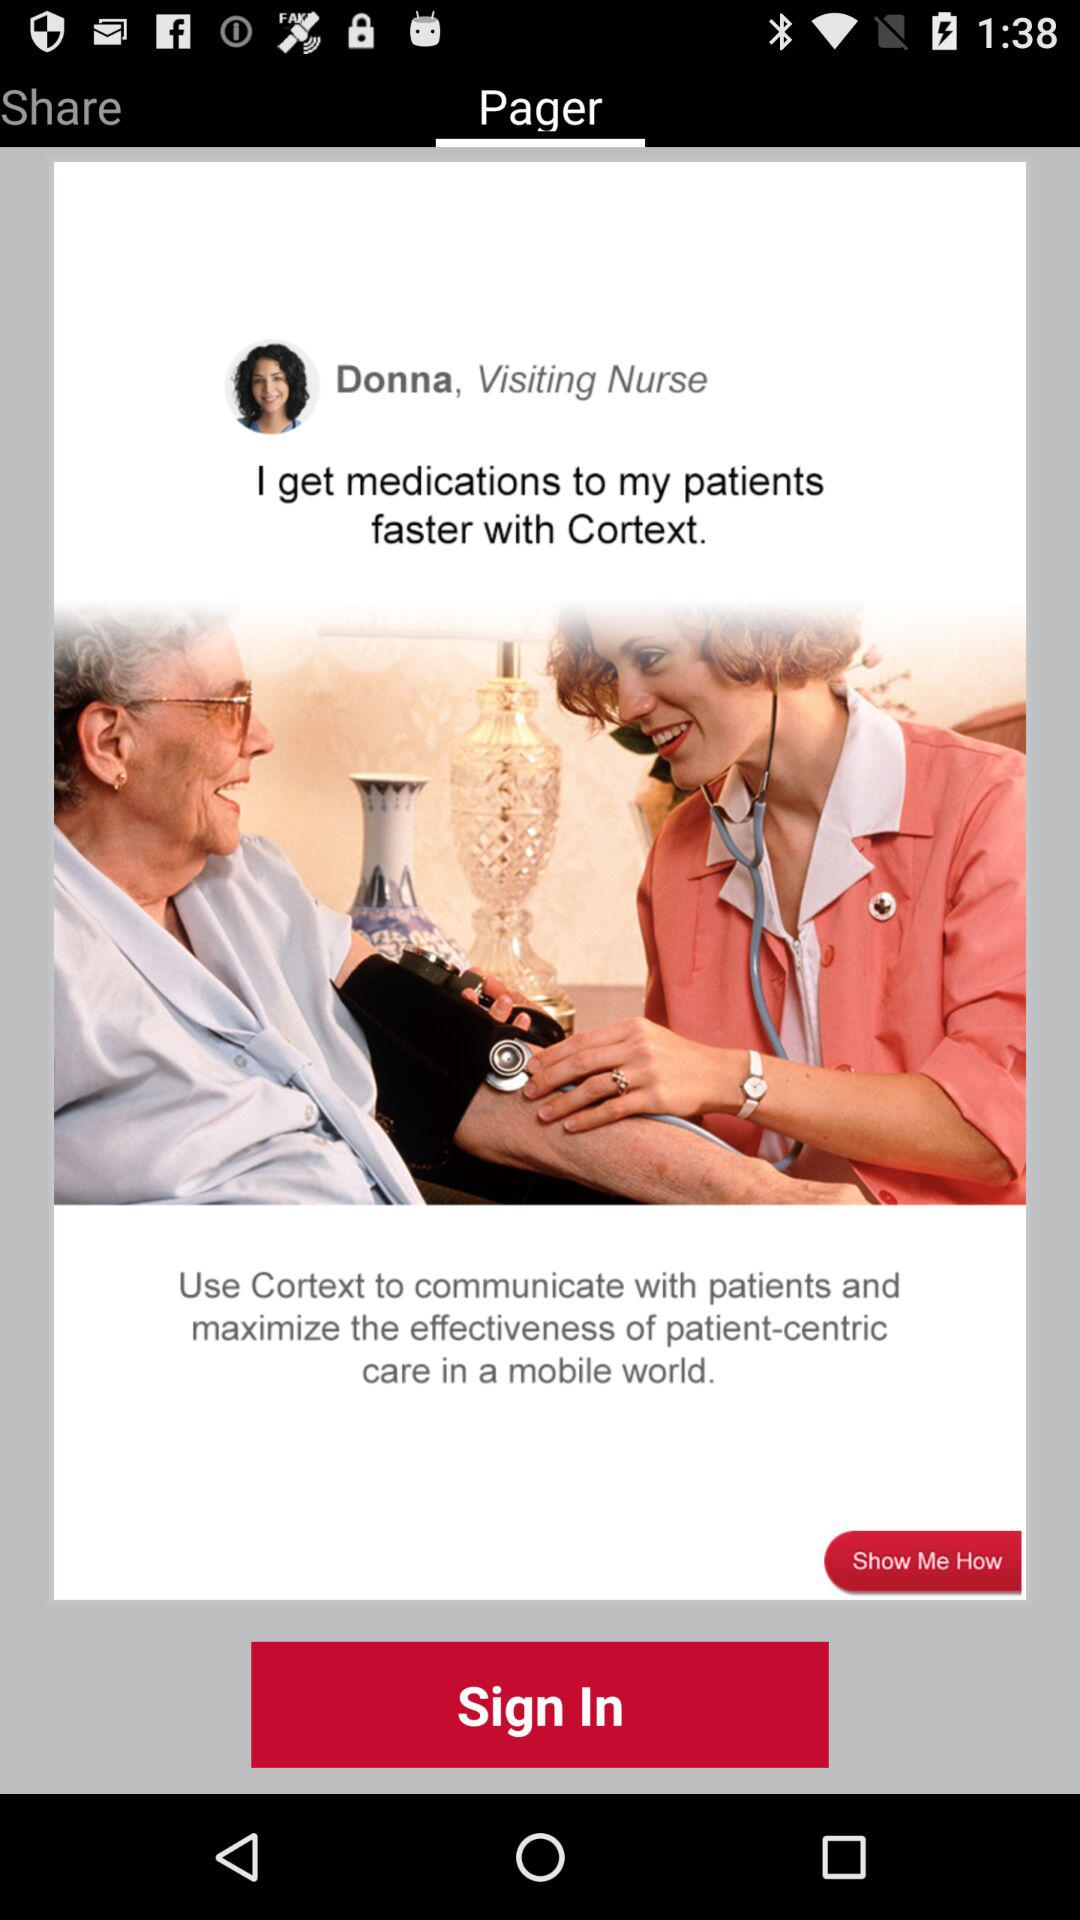Which tab am I on? You are on the "Pager" tab. 